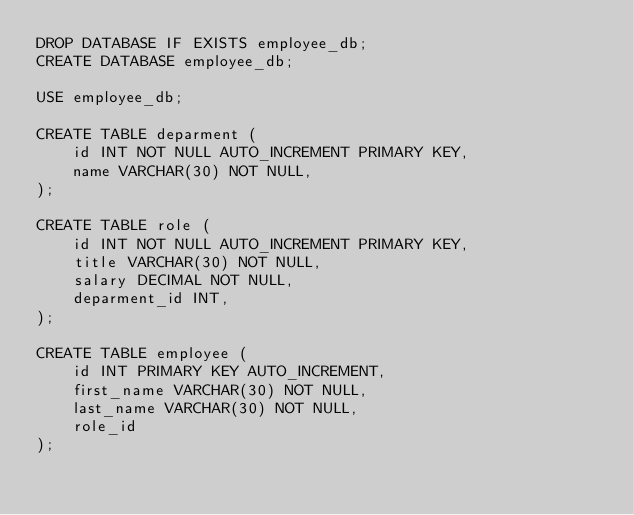Convert code to text. <code><loc_0><loc_0><loc_500><loc_500><_SQL_>DROP DATABASE IF EXISTS employee_db;
CREATE DATABASE employee_db;

USE employee_db;

CREATE TABLE deparment (
    id INT NOT NULL AUTO_INCREMENT PRIMARY KEY,
    name VARCHAR(30) NOT NULL,
);

CREATE TABLE role (
    id INT NOT NULL AUTO_INCREMENT PRIMARY KEY,
    title VARCHAR(30) NOT NULL,
    salary DECIMAL NOT NULL,
    deparment_id INT,
);

CREATE TABLE employee (
    id INT PRIMARY KEY AUTO_INCREMENT,
    first_name VARCHAR(30) NOT NULL,
    last_name VARCHAR(30) NOT NULL,
    role_id
);</code> 